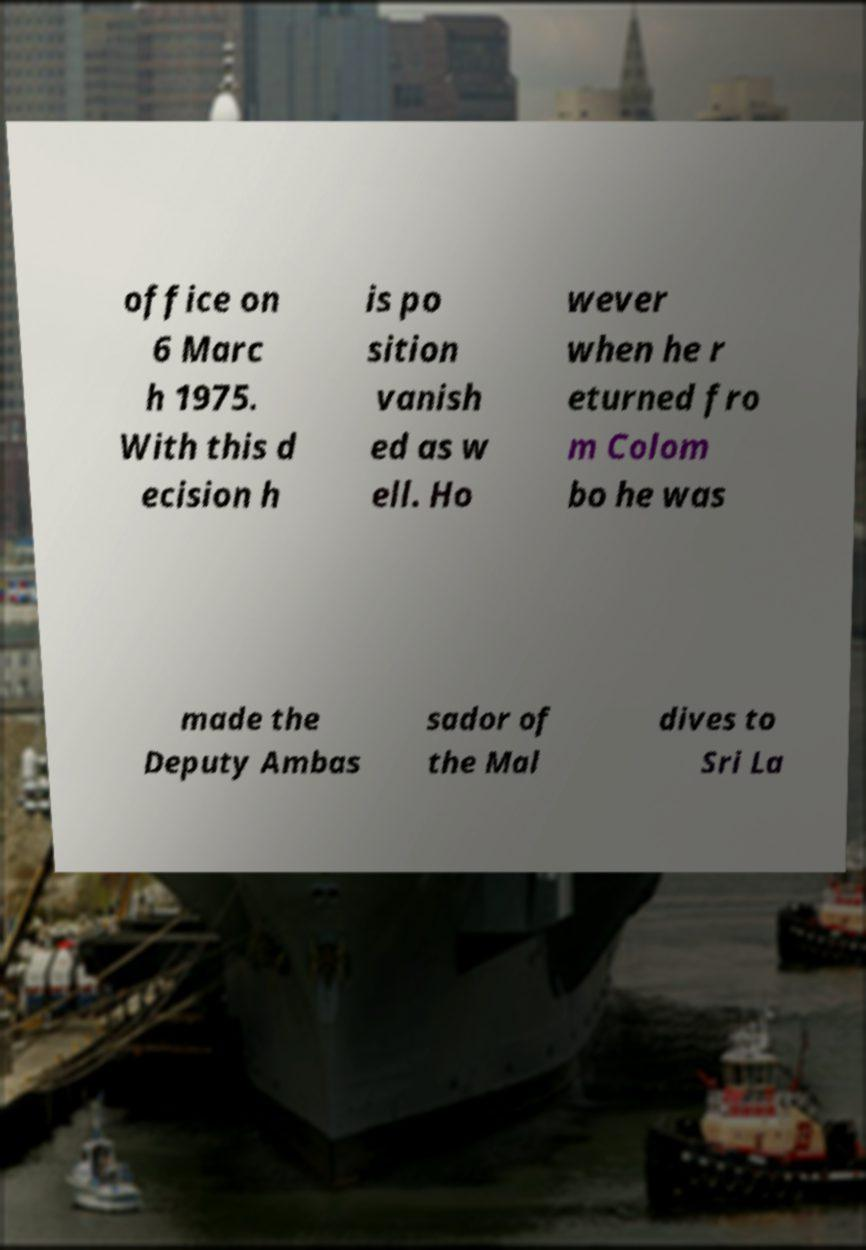There's text embedded in this image that I need extracted. Can you transcribe it verbatim? office on 6 Marc h 1975. With this d ecision h is po sition vanish ed as w ell. Ho wever when he r eturned fro m Colom bo he was made the Deputy Ambas sador of the Mal dives to Sri La 